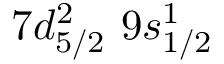<formula> <loc_0><loc_0><loc_500><loc_500>7 d _ { 5 / 2 } ^ { 2 } \, 9 s _ { 1 / 2 } ^ { 1 }</formula> 